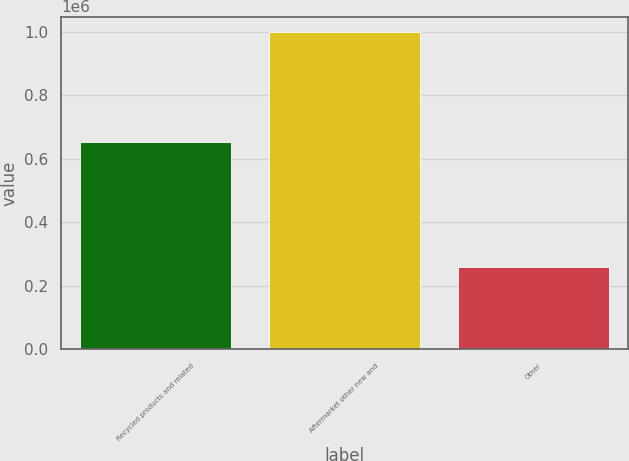<chart> <loc_0><loc_0><loc_500><loc_500><bar_chart><fcel>Recycled products and related<fcel>Aftermarket other new and<fcel>Other<nl><fcel>651803<fcel>998541<fcel>258188<nl></chart> 